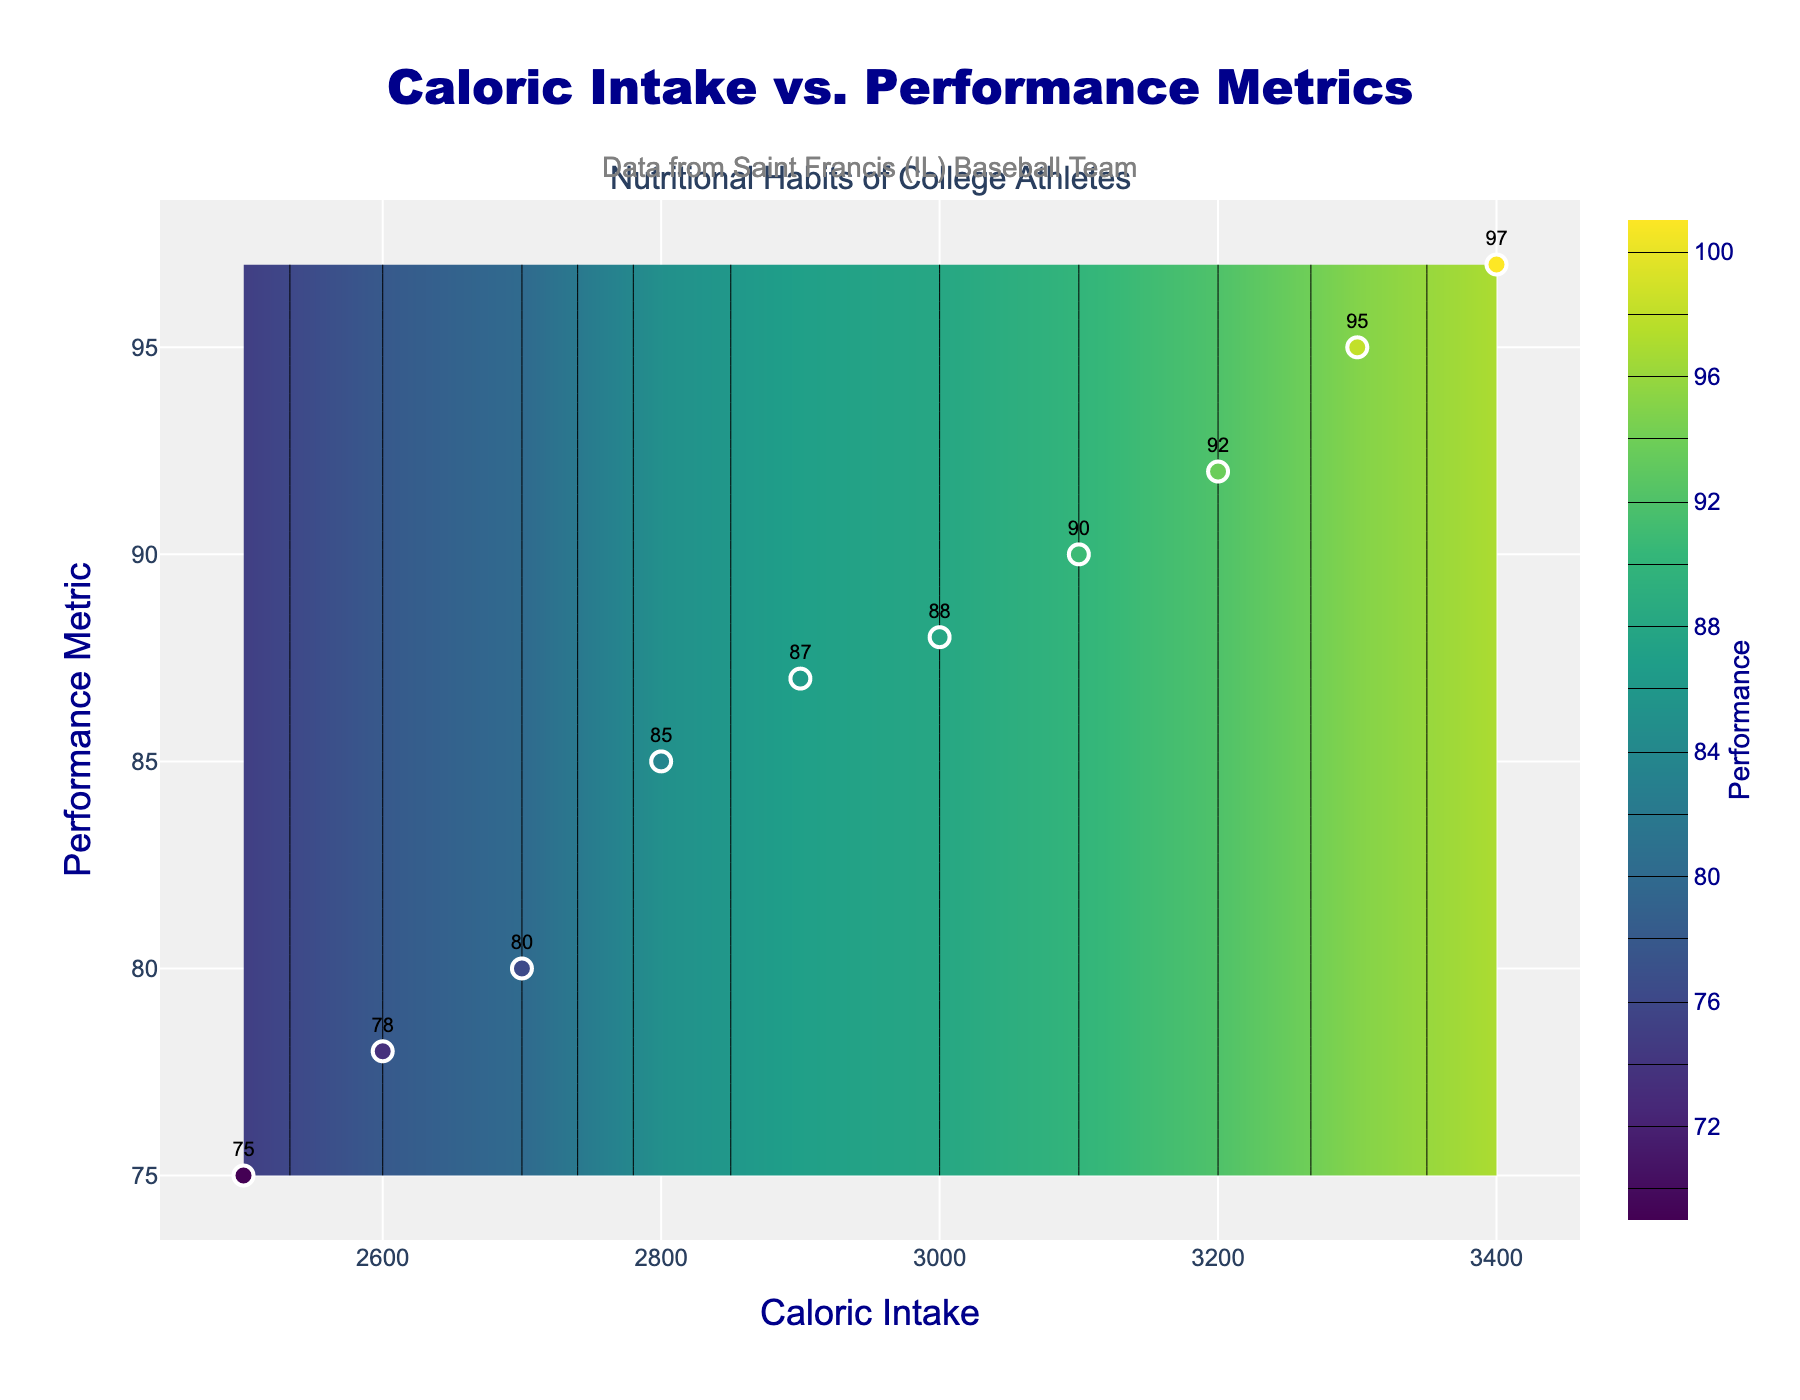What is the title of the figure? The title is located at the top center of the figure; it states "Caloric Intake vs. Performance Metrics."
Answer: Caloric Intake vs. Performance Metrics What is the color of the contours on the figure? The contours on the figure are colored using the Viridis color scale, which transitions from dark purples to yellows.
Answer: Viridis color scale How many data points are shown in the scatter plot? Count the number of markers (dots) on the plot; there are 10 data points visible in the scatter plot.
Answer: 10 What is the performance metric value for a caloric intake of 2900? Locate the x-coordinate 2900 on the caloric intake axis and find the corresponding y-coordinate from the plotted data points. It intersects the point labeled with a performance metric of 87.
Answer: 87 Which caloric intake value corresponds to the highest performance metric? Identify the highest y-coordinate among the plotted data points, which is 97. Then check the x-coordinate corresponding to that point, which is 3400.
Answer: 3400 What interval is used for the contour lines in the plot? The contour is subdivided based on performance levels ranging from 70 to 100 by an increment of 2.
Answer: 2 What is the performance metric for a caloric intake of 3000? Locate the point on the scatter plot where the x-coordinate is 3000. The y-coordinate for this data point is labeled as 88.
Answer: 88 What is the average caloric intake for the given performance metrics? Sum all values of caloric intake (2500+2600+2700+2800+2900+3000+3100+3200+3300+3400) which is 29500, and divide by the number of points (10). The average is 29500/10, resulting in 2950.
Answer: 2950 Compare the performance metrics at 2600 and 3200 caloric intake. Locate the data points for caloric intake values 2600 and 3200 on the scatter plot. The performance metric for 2600 is 78 and for 3200 is 92. So, 92 is greater than 78.
Answer: 92 > 78 What is the range of performance metrics among the data points? Identify the minimum and maximum performance metric values in the scatter plot, which are 75 and 97, respectively. The range is 97 - 75 = 22.
Answer: 22 